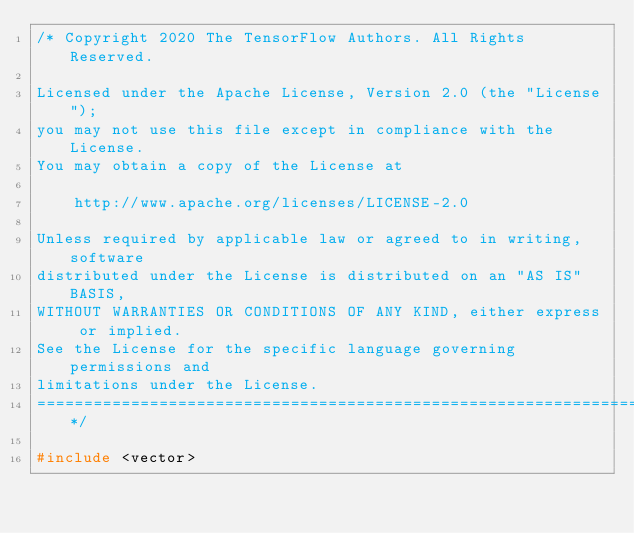Convert code to text. <code><loc_0><loc_0><loc_500><loc_500><_C++_>/* Copyright 2020 The TensorFlow Authors. All Rights Reserved.

Licensed under the Apache License, Version 2.0 (the "License");
you may not use this file except in compliance with the License.
You may obtain a copy of the License at

    http://www.apache.org/licenses/LICENSE-2.0

Unless required by applicable law or agreed to in writing, software
distributed under the License is distributed on an "AS IS" BASIS,
WITHOUT WARRANTIES OR CONDITIONS OF ANY KIND, either express or implied.
See the License for the specific language governing permissions and
limitations under the License.
==============================================================================*/

#include <vector>
</code> 